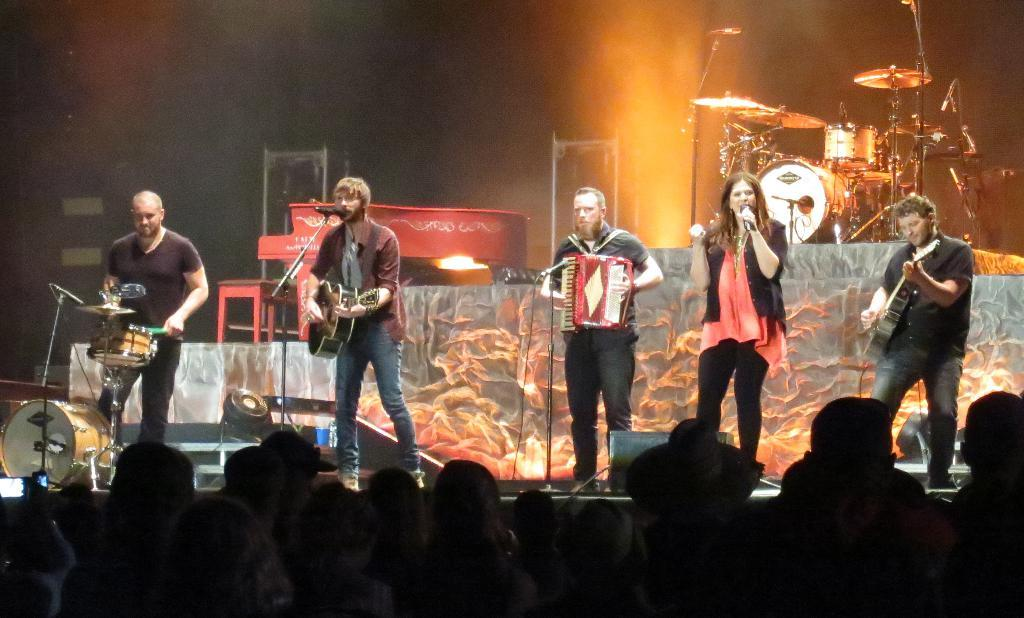What activity is the group of people engaged in? The group of people is playing music. Can you describe the roles of the two people in front of the microphone? Two people are singing in front of a microphone. What type of instrument can be seen in the background? There are drums in the background. Who is present to watch the musicians perform? There is an audience in front of the musicians. What type of calculator is being used by the drummer in the image? There is no calculator present in the image, as the focus is on the musicians playing music. Can you describe the celery being chopped by the audience member in the image? There is no celery or chopping activity present in the image; the focus is on the musicians and the audience. 